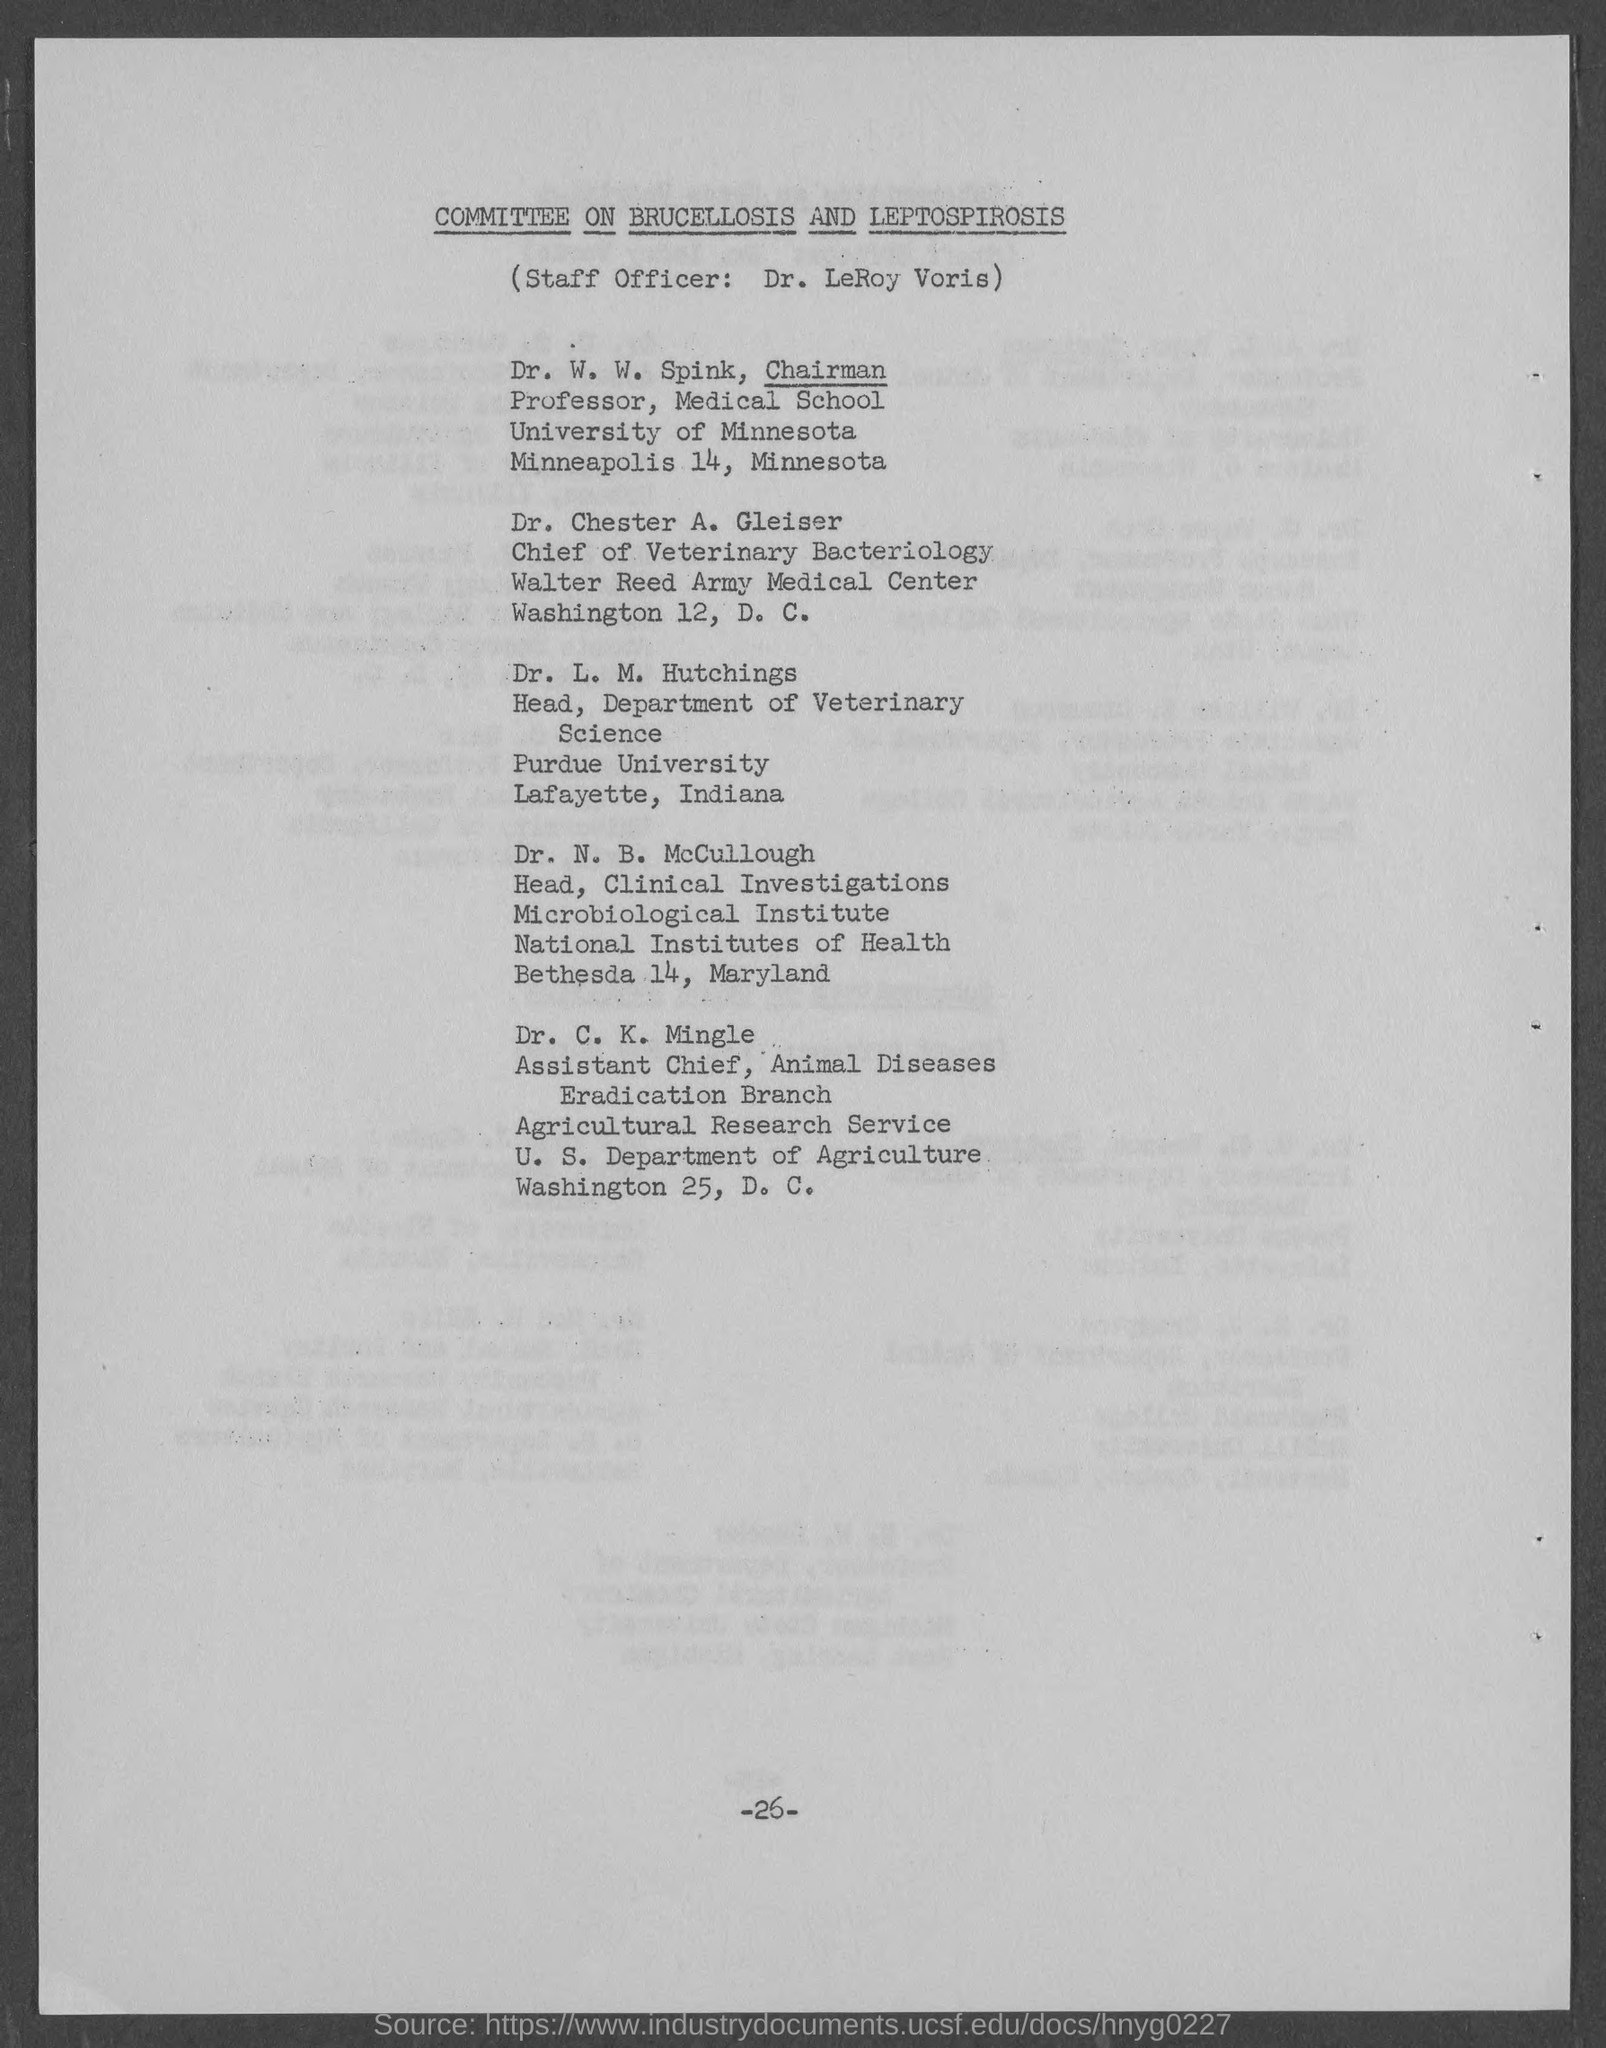What is the document title?
Offer a terse response. Committee on Brucellosis and Leptospirosis. Who is the staff officer?
Keep it short and to the point. Dr. LeRoy Voris. Who is the Chairman?
Provide a succinct answer. Dr. W. W. Spink. What is the title of Dr. Chester A. Gleiser?
Your response must be concise. Chief of Veterinary Bacteriology. Who is the head of Department of Veterinary Science?
Your answer should be compact. Dr. L. M. Hutchings. What is the page number on this document?
Give a very brief answer. -26-. 